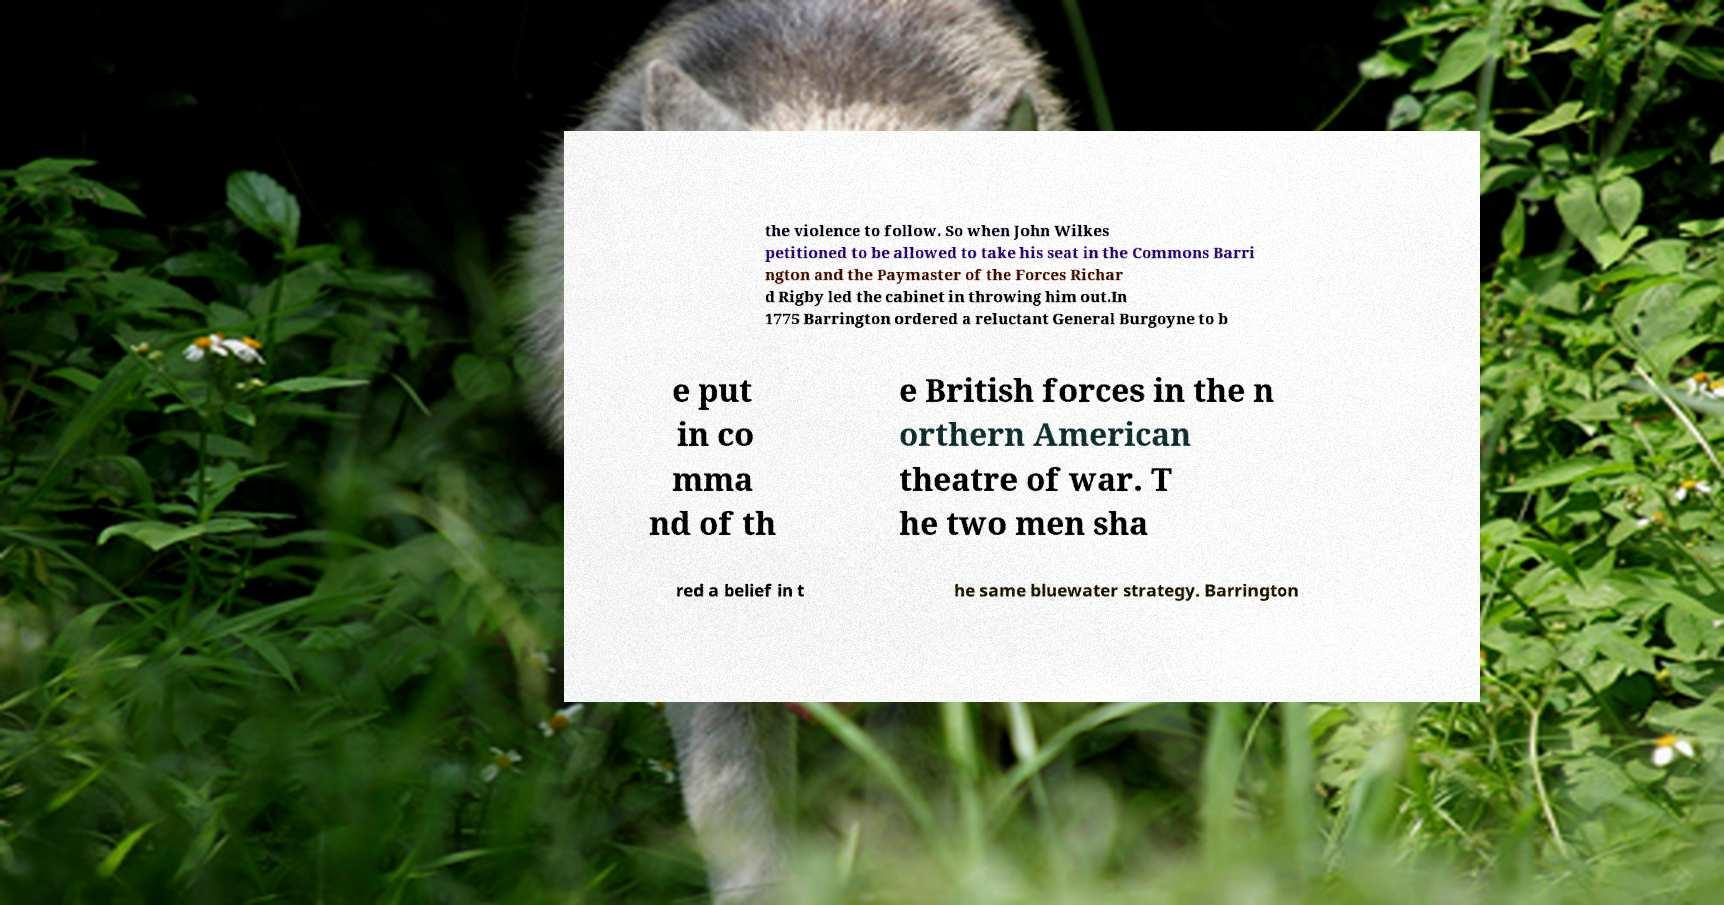For documentation purposes, I need the text within this image transcribed. Could you provide that? the violence to follow. So when John Wilkes petitioned to be allowed to take his seat in the Commons Barri ngton and the Paymaster of the Forces Richar d Rigby led the cabinet in throwing him out.In 1775 Barrington ordered a reluctant General Burgoyne to b e put in co mma nd of th e British forces in the n orthern American theatre of war. T he two men sha red a belief in t he same bluewater strategy. Barrington 